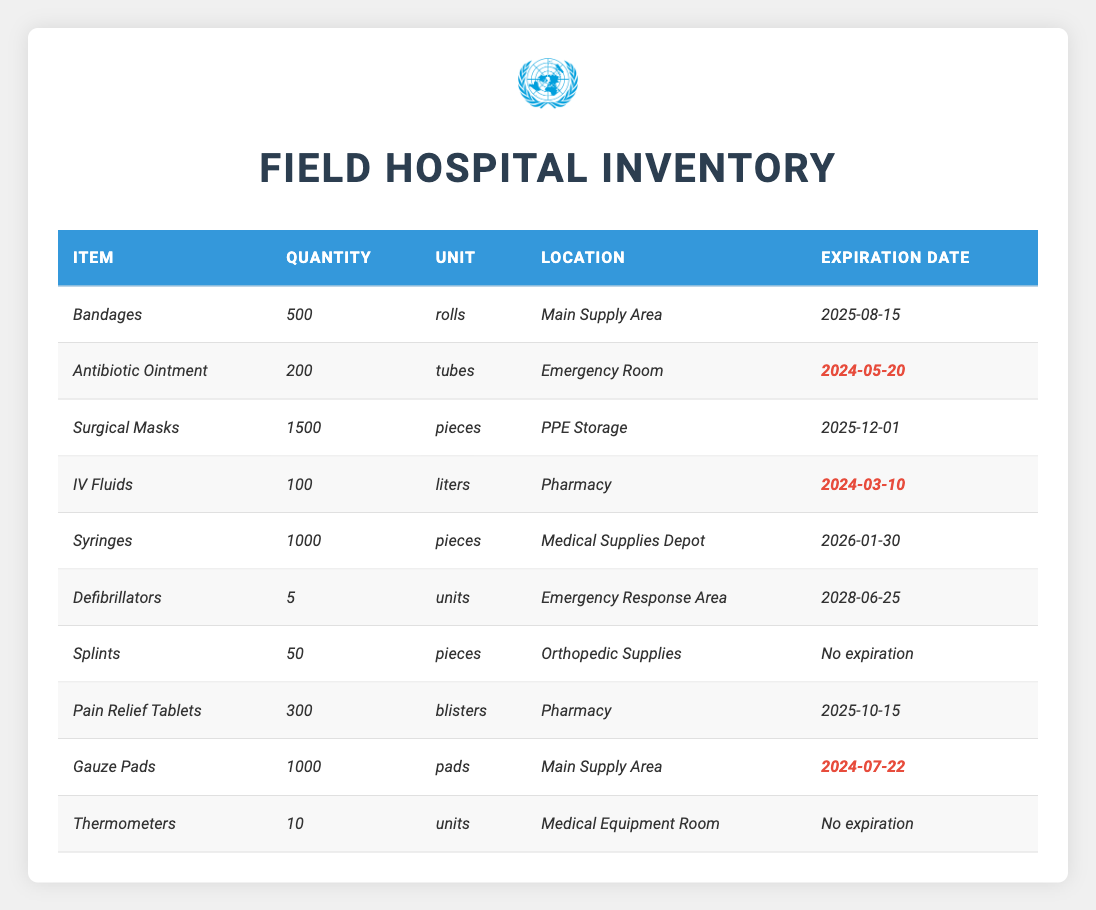What is the total number of *Syringes* in inventory? The table lists *Syringes* with a quantity of *1000*. There are no other entries for *Syringes*, so the total is simply *1000*.
Answer: 1000 Which item in the inventory has the earliest expiration date? The expiration dates for the items are *2025-08-15*, *2024-05-20*, *2025-12-01*, *2024-03-10*, *2026-01-30*, *2028-06-25*, *No expiration*, *2025-10-15*, *2024-07-22*, and *No expiration*. Among these, *IV Fluids* expire on *2024-03-10*, which is the earliest date.
Answer: IV Fluids Is the quantity of *Defibrillators* greater than *10*? The table indicates that there are *5 Defibrillators*. Thus, the quantity is not greater than *10*.
Answer: No How many items have an expiration date of *No expiration*? From the table, *Splints* and *Thermometers* are the only items with *No expiration*. Therefore, there are *2* items.
Answer: 2 What is the total quantity of medical supplies that are expiring in *2024*? The items with expiration dates in 2024 are *Antibiotic Ointment* (200), *IV Fluids* (100), and *Gauze Pads* (1000). Adding these together gives 200 + 100 + 1000 = 1300.
Answer: 1300 Which location has the most quantity of items? The *Main Supply Area* has *500 rolls of Bandages* and *1000 pads of Gauze*, totaling *1500*. The other locations have fewer quantities combined.
Answer: Main Supply Area Is there any item with a quantity less than *50*? The table shows item quantities as *500, 200, 1500, 100, 1000, 5, 50, 300, 1000, and 10*. The only quantity less than *50* is the *5 Defibrillators*.
Answer: Yes How many more *Surgical Masks* are there than *Pain Relief Tablets*? The quantity of *Surgical Masks* is *1500* and *Pain Relief Tablets* has *300*. The difference is 1500 - 300 = 1200.
Answer: 1200 What percentage of total inventory does *Bandages* represent? First, calculate the total quantity: 500 (Bandages) + 200 + 1500 + 100 + 1000 + 5 + 50 + 300 + 1000 + 10 = 3665. Then calculate the percentage for Bandages: (500 / 3665) * 100 ≈ 13.65%.
Answer: 13.65% Are there more items in the *Pharmacy* than *Emergency Room*? The *Pharmacy* contains *IV Fluids* (100) and *Pain Relief Tablets* (300), totaling *400*. The *Emergency Room* has *Antibiotic Ointment* with *200*. Since 400 > 200, yes.
Answer: Yes 